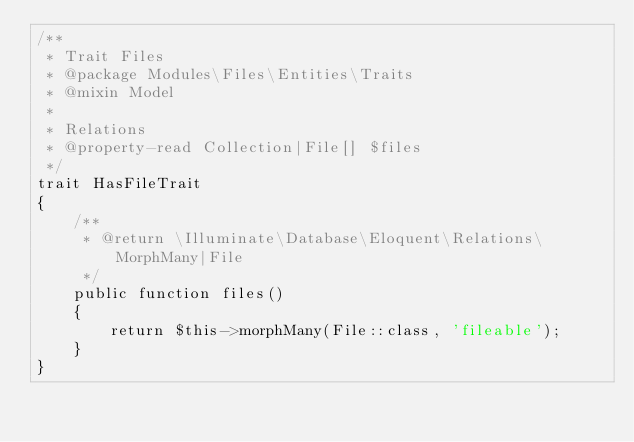<code> <loc_0><loc_0><loc_500><loc_500><_PHP_>/**
 * Trait Files
 * @package Modules\Files\Entities\Traits
 * @mixin Model
 *
 * Relations
 * @property-read Collection|File[] $files
 */
trait HasFileTrait
{
    /**
     * @return \Illuminate\Database\Eloquent\Relations\MorphMany|File
     */
    public function files()
    {
        return $this->morphMany(File::class, 'fileable');
    }
}
</code> 